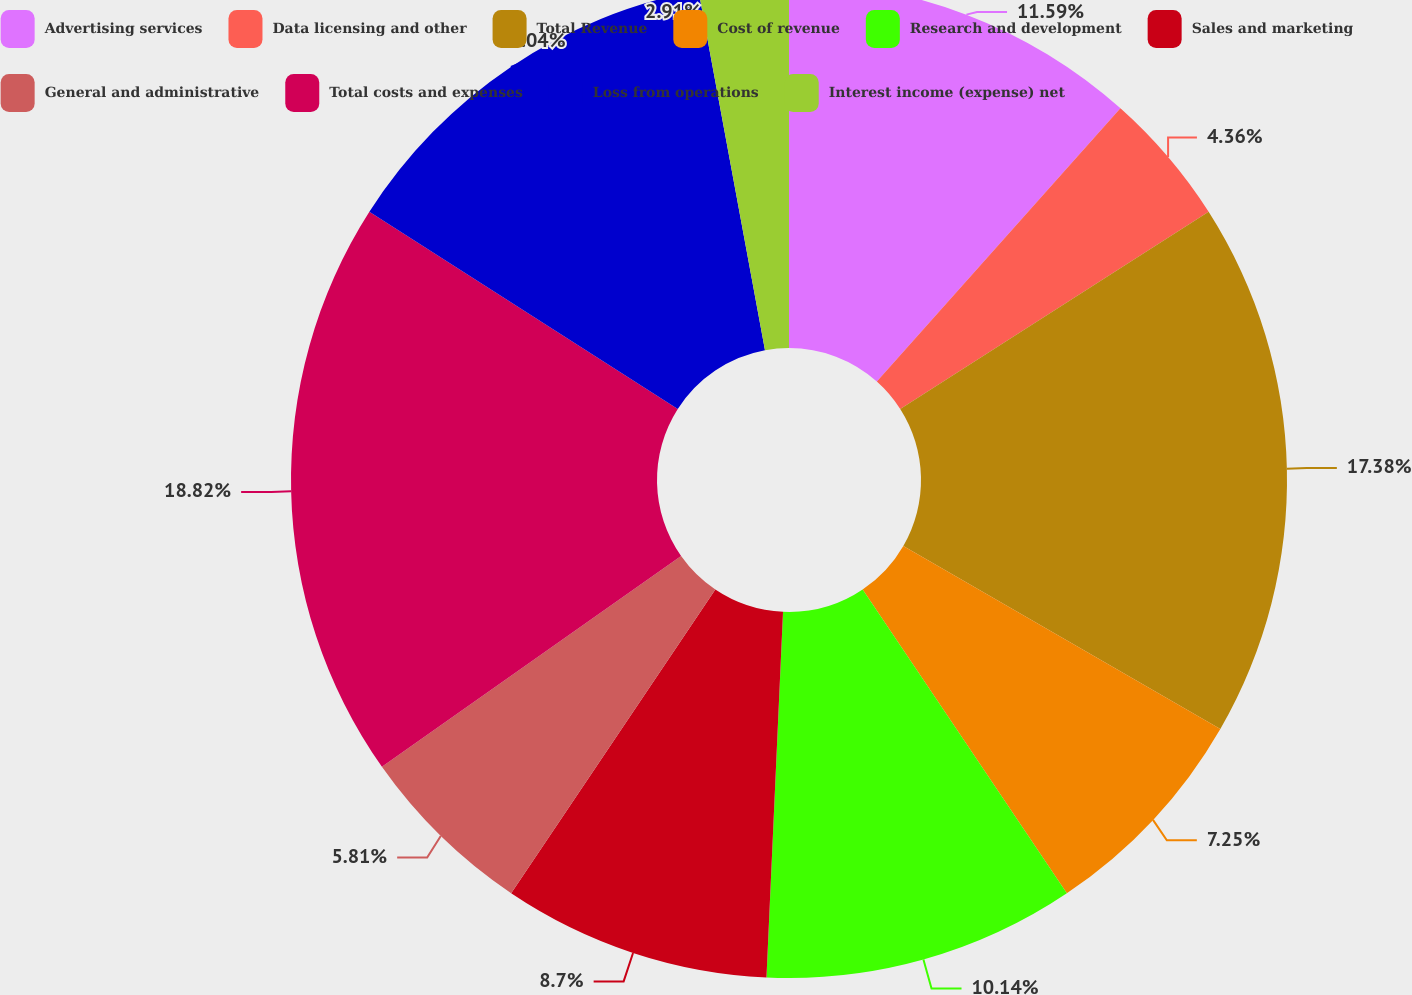Convert chart to OTSL. <chart><loc_0><loc_0><loc_500><loc_500><pie_chart><fcel>Advertising services<fcel>Data licensing and other<fcel>Total Revenue<fcel>Cost of revenue<fcel>Research and development<fcel>Sales and marketing<fcel>General and administrative<fcel>Total costs and expenses<fcel>Loss from operations<fcel>Interest income (expense) net<nl><fcel>11.59%<fcel>4.36%<fcel>17.38%<fcel>7.25%<fcel>10.14%<fcel>8.7%<fcel>5.81%<fcel>18.82%<fcel>13.04%<fcel>2.91%<nl></chart> 